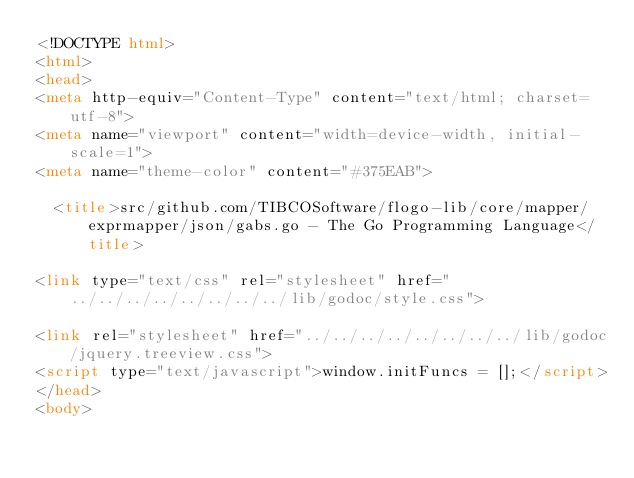Convert code to text. <code><loc_0><loc_0><loc_500><loc_500><_HTML_><!DOCTYPE html>
<html>
<head>
<meta http-equiv="Content-Type" content="text/html; charset=utf-8">
<meta name="viewport" content="width=device-width, initial-scale=1">
<meta name="theme-color" content="#375EAB">

  <title>src/github.com/TIBCOSoftware/flogo-lib/core/mapper/exprmapper/json/gabs.go - The Go Programming Language</title>

<link type="text/css" rel="stylesheet" href="../../../../../../../../lib/godoc/style.css">

<link rel="stylesheet" href="../../../../../../../../lib/godoc/jquery.treeview.css">
<script type="text/javascript">window.initFuncs = [];</script>
</head>
<body>
</code> 